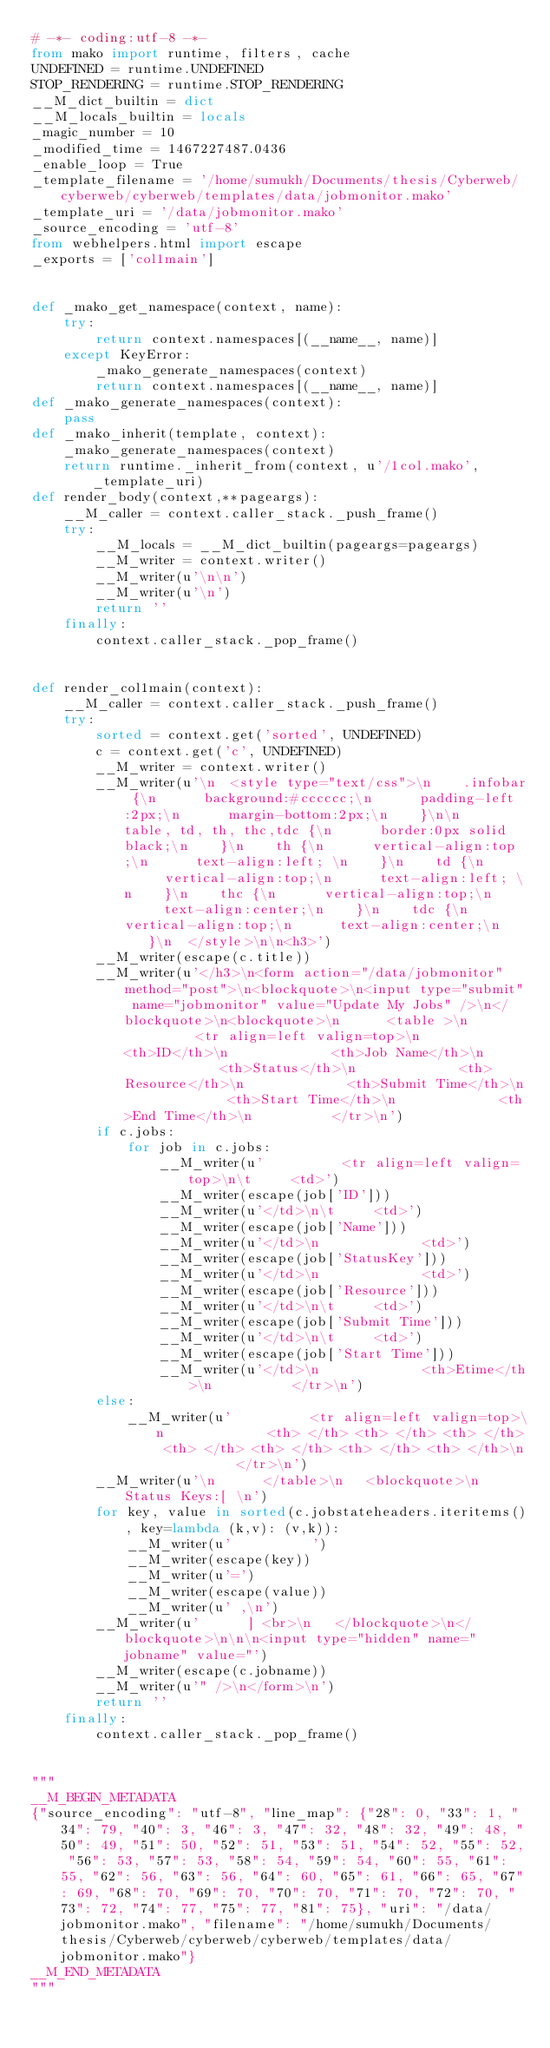Convert code to text. <code><loc_0><loc_0><loc_500><loc_500><_Python_># -*- coding:utf-8 -*-
from mako import runtime, filters, cache
UNDEFINED = runtime.UNDEFINED
STOP_RENDERING = runtime.STOP_RENDERING
__M_dict_builtin = dict
__M_locals_builtin = locals
_magic_number = 10
_modified_time = 1467227487.0436
_enable_loop = True
_template_filename = '/home/sumukh/Documents/thesis/Cyberweb/cyberweb/cyberweb/templates/data/jobmonitor.mako'
_template_uri = '/data/jobmonitor.mako'
_source_encoding = 'utf-8'
from webhelpers.html import escape
_exports = ['col1main']


def _mako_get_namespace(context, name):
    try:
        return context.namespaces[(__name__, name)]
    except KeyError:
        _mako_generate_namespaces(context)
        return context.namespaces[(__name__, name)]
def _mako_generate_namespaces(context):
    pass
def _mako_inherit(template, context):
    _mako_generate_namespaces(context)
    return runtime._inherit_from(context, u'/1col.mako', _template_uri)
def render_body(context,**pageargs):
    __M_caller = context.caller_stack._push_frame()
    try:
        __M_locals = __M_dict_builtin(pageargs=pageargs)
        __M_writer = context.writer()
        __M_writer(u'\n\n')
        __M_writer(u'\n')
        return ''
    finally:
        context.caller_stack._pop_frame()


def render_col1main(context):
    __M_caller = context.caller_stack._push_frame()
    try:
        sorted = context.get('sorted', UNDEFINED)
        c = context.get('c', UNDEFINED)
        __M_writer = context.writer()
        __M_writer(u'\n  <style type="text/css">\n    .infobar {\n      background:#cccccc;\n      padding-left:2px;\n      margin-bottom:2px;\n    }\n\n    table, td, th, thc,tdc {\n      border:0px solid black;\n    }\n    th {\n      vertical-align:top;\n      text-align:left; \n    }\n    td {\n      vertical-align:top;\n      text-align:left; \n    }\n    thc {\n      vertical-align:top;\n      text-align:center;\n    }\n    tdc {\n      vertical-align:top;\n      text-align:center;\n    }\n  </style>\n\n<h3>')
        __M_writer(escape(c.title))
        __M_writer(u'</h3>\n<form action="/data/jobmonitor" method="post">\n<blockquote>\n<input type="submit" name="jobmonitor" value="Update My Jobs" />\n</blockquote>\n<blockquote>\n      <table >\n          <tr align=left valign=top>\n             <th>ID</th>\n             <th>Job Name</th>\n             <th>Status</th>\n             <th>Resource</th>\n             <th>Submit Time</th>\n             <th>Start Time</th>\n             <th>End Time</th>\n          </tr>\n')
        if c.jobs:
            for job in c.jobs:
                __M_writer(u'          <tr align=left valign=top>\n\t     <td>')
                __M_writer(escape(job['ID']))
                __M_writer(u'</td>\n\t     <td>')
                __M_writer(escape(job['Name']))
                __M_writer(u'</td>\n             <td>')
                __M_writer(escape(job['StatusKey']))
                __M_writer(u'</td>\n             <td>')
                __M_writer(escape(job['Resource']))
                __M_writer(u'</td>\n\t     <td>')
                __M_writer(escape(job['Submit Time']))
                __M_writer(u'</td>\n\t     <td>')
                __M_writer(escape(job['Start Time']))
                __M_writer(u'</td>\n             <th>Etime</th>\n          </tr>\n')
        else:
            __M_writer(u'          <tr align=left valign=top>\n             <th> </th> <th> </th> <th> </th> <th> </th> <th> </th> <th> </th> <th> </th>\n          </tr>\n')
        __M_writer(u'\n      </table>\n   <blockquote>\n      Status Keys:[ \n')
        for key, value in sorted(c.jobstateheaders.iteritems(), key=lambda (k,v): (v,k)):
            __M_writer(u'          ')
            __M_writer(escape(key))
            __M_writer(u'=')
            __M_writer(escape(value))
            __M_writer(u' ,\n')
        __M_writer(u'      ] <br>\n   </blockquote>\n</blockquote>\n\n\n<input type="hidden" name="jobname" value="')
        __M_writer(escape(c.jobname))
        __M_writer(u'" />\n</form>\n')
        return ''
    finally:
        context.caller_stack._pop_frame()


"""
__M_BEGIN_METADATA
{"source_encoding": "utf-8", "line_map": {"28": 0, "33": 1, "34": 79, "40": 3, "46": 3, "47": 32, "48": 32, "49": 48, "50": 49, "51": 50, "52": 51, "53": 51, "54": 52, "55": 52, "56": 53, "57": 53, "58": 54, "59": 54, "60": 55, "61": 55, "62": 56, "63": 56, "64": 60, "65": 61, "66": 65, "67": 69, "68": 70, "69": 70, "70": 70, "71": 70, "72": 70, "73": 72, "74": 77, "75": 77, "81": 75}, "uri": "/data/jobmonitor.mako", "filename": "/home/sumukh/Documents/thesis/Cyberweb/cyberweb/cyberweb/templates/data/jobmonitor.mako"}
__M_END_METADATA
"""
</code> 